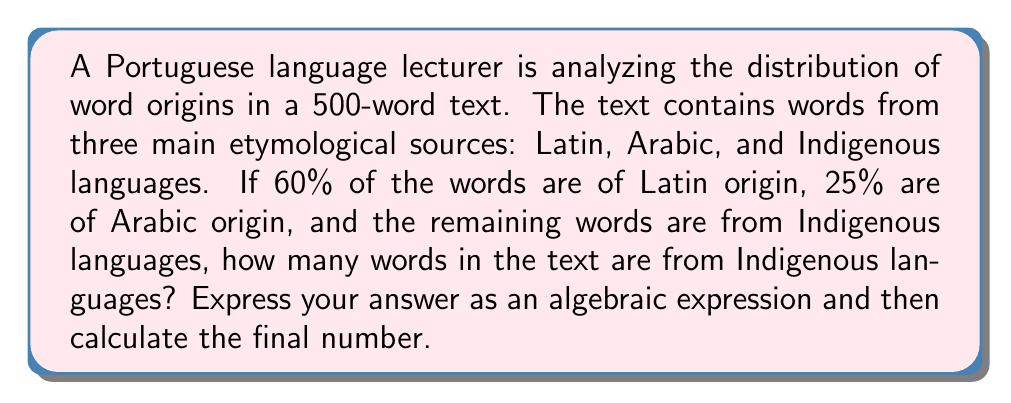Could you help me with this problem? Let's approach this step-by-step:

1) First, let's define our variables:
   Let $x$ be the total number of words in the text (which we know is 500)
   Let $y$ be the number of words from Indigenous languages (which we need to find)

2) We know that:
   - 60% of words are of Latin origin
   - 25% of words are of Arabic origin
   - The remaining words are from Indigenous languages

3) We can express this as an equation:
   $$ 0.60x + 0.25x + y = x $$

4) Simplify the left side of the equation:
   $$ 0.85x + y = x $$

5) Subtract $0.85x$ from both sides:
   $$ y = x - 0.85x = 0.15x $$

6) Now we can substitute the known value of $x$:
   $$ y = 0.15 * 500 $$

7) Calculate the final result:
   $$ y = 75 $$
Answer: The algebraic expression for the number of words from Indigenous languages is $y = 0.15x$, where $x$ is the total number of words. 
The final answer is 75 words. 